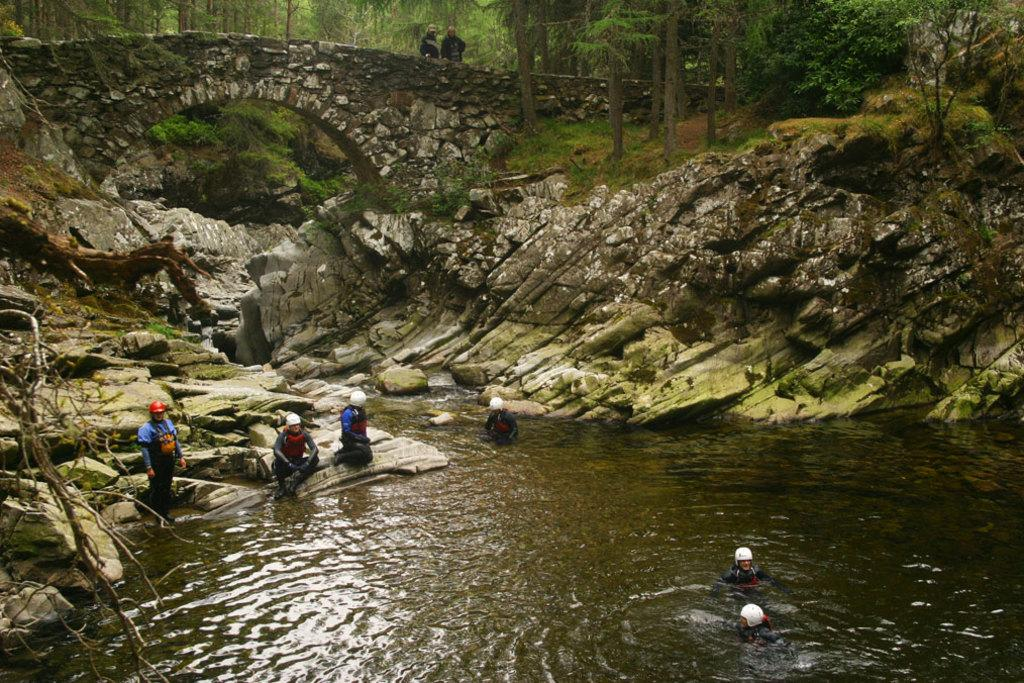How many people are in the image? There is a group of people in the image. Where are some of the people located in the image? Some people are in the water, and some are on a rock. What can be seen in the background of the image? There is a rock and many trees in the background. Are there any other people visible in the background? Yes, there are two more people in the background. What type of furniture can be seen in the image? There is no furniture present in the image. Can you describe the motion of the cat in the image? There is no cat present in the image. 